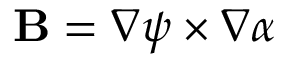<formula> <loc_0><loc_0><loc_500><loc_500>B = \nabla \psi \times \nabla \alpha</formula> 